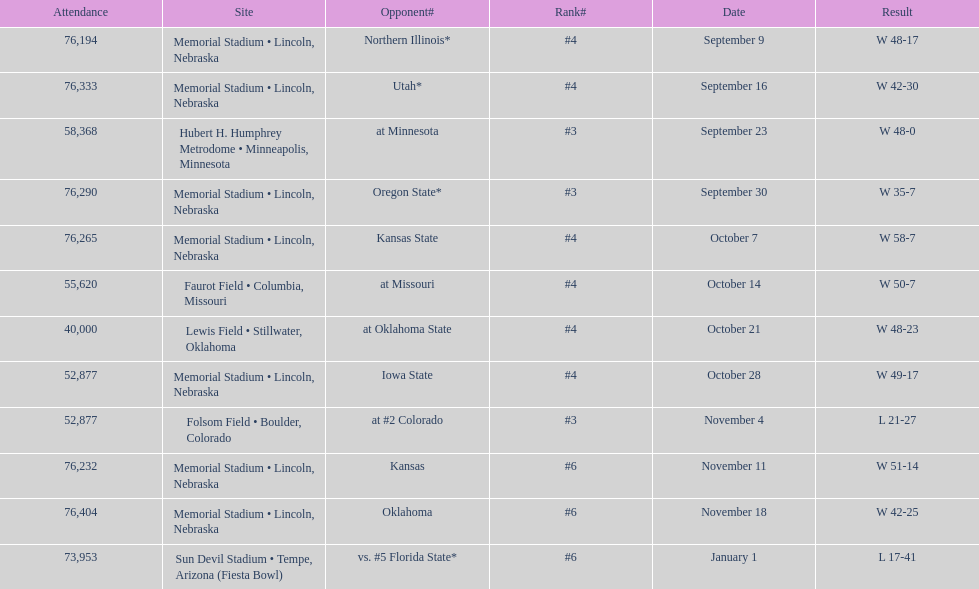Which month is listed the least on this chart? January. 